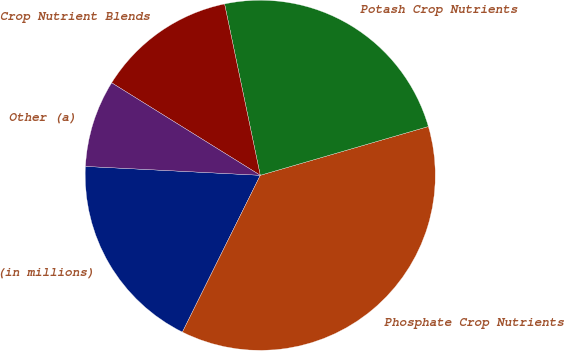<chart> <loc_0><loc_0><loc_500><loc_500><pie_chart><fcel>(in millions)<fcel>Phosphate Crop Nutrients<fcel>Potash Crop Nutrients<fcel>Crop Nutrient Blends<fcel>Other (a)<nl><fcel>18.47%<fcel>36.83%<fcel>23.77%<fcel>12.87%<fcel>8.05%<nl></chart> 